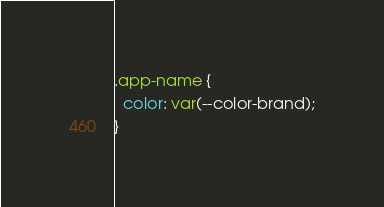<code> <loc_0><loc_0><loc_500><loc_500><_CSS_>.app-name {
  color: var(--color-brand);
}
</code> 